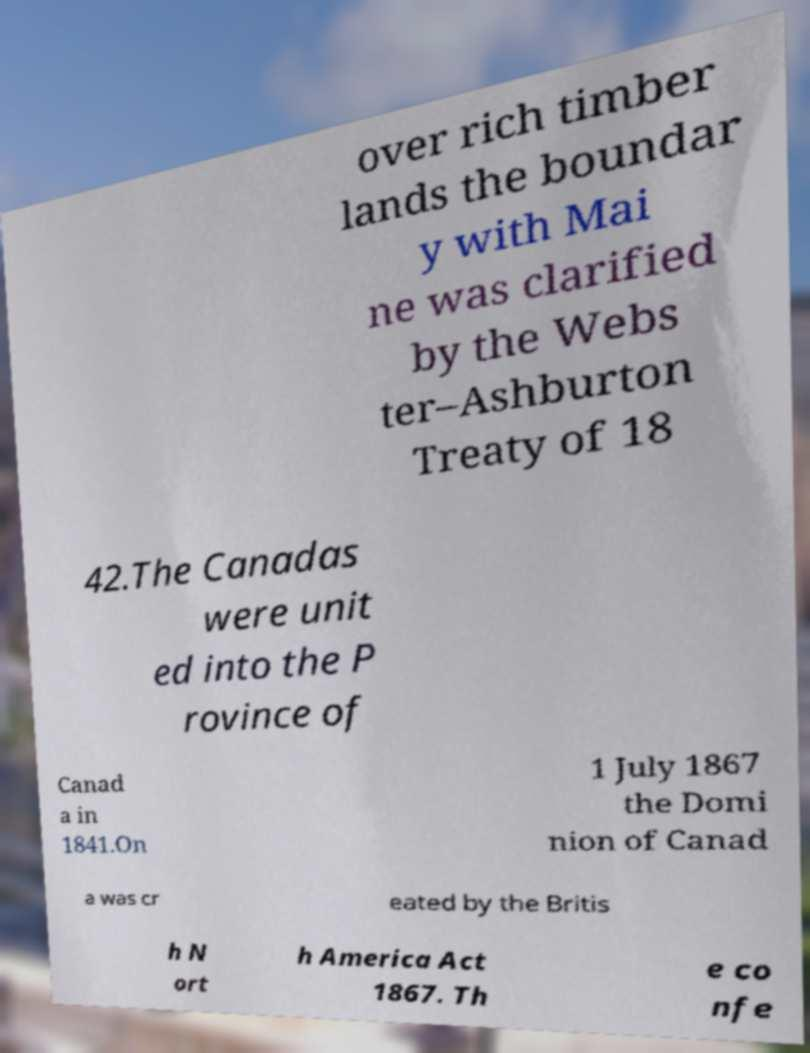For documentation purposes, I need the text within this image transcribed. Could you provide that? over rich timber lands the boundar y with Mai ne was clarified by the Webs ter–Ashburton Treaty of 18 42.The Canadas were unit ed into the P rovince of Canad a in 1841.On 1 July 1867 the Domi nion of Canad a was cr eated by the Britis h N ort h America Act 1867. Th e co nfe 